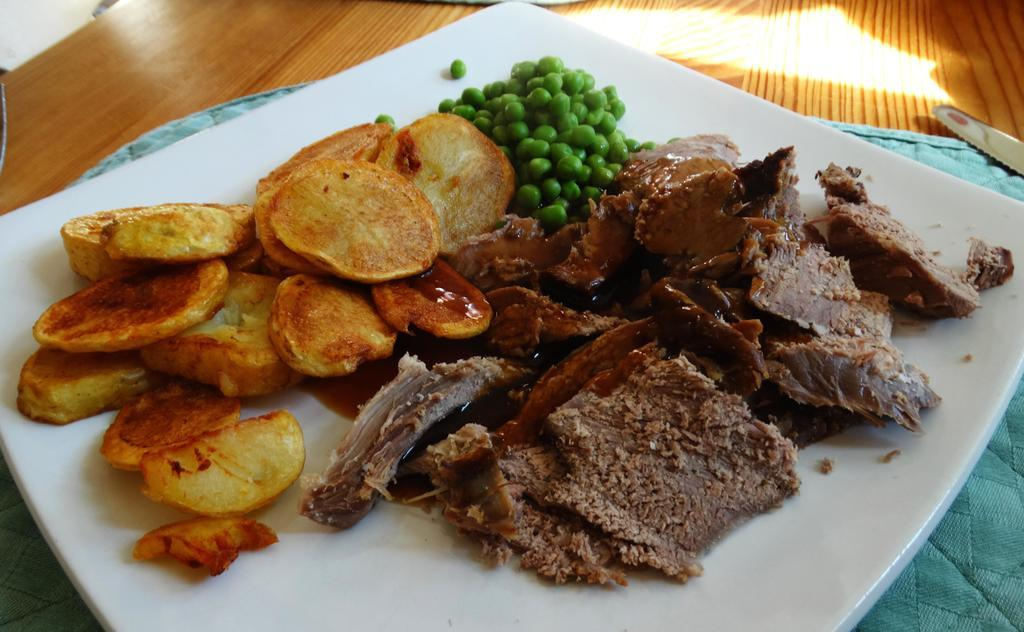What is in the plate that is visible in the center of the image? There are food items in a plate in the center of the image. What is located at the bottom of the image? There is a table at the bottom of the image. What color is the cloth in the image? There is a green color cloth in the image. How many pins are holding the hair in place in the image? There are no pins or hair present in the image. What type of floor is visible in the image? The image does not show the floor; it only shows a table and a plate of food items. 